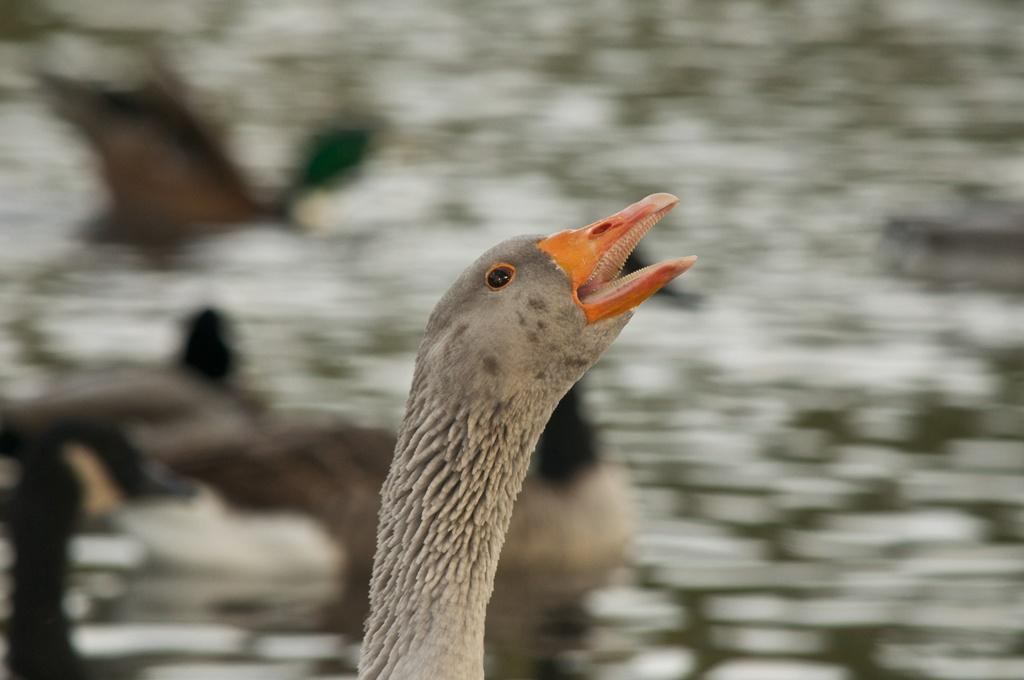What is the main subject of the image? There is a bird in the center of the image. Can you describe the bird in the image? Unfortunately, the image does not provide enough detail to describe the bird. What is the bird's location in the image? The bird is in the center of the image. How far is the bird's vacation destination from its current location in the image? There is no indication of a vacation or a destination in the image, as it only features a bird in the center. 